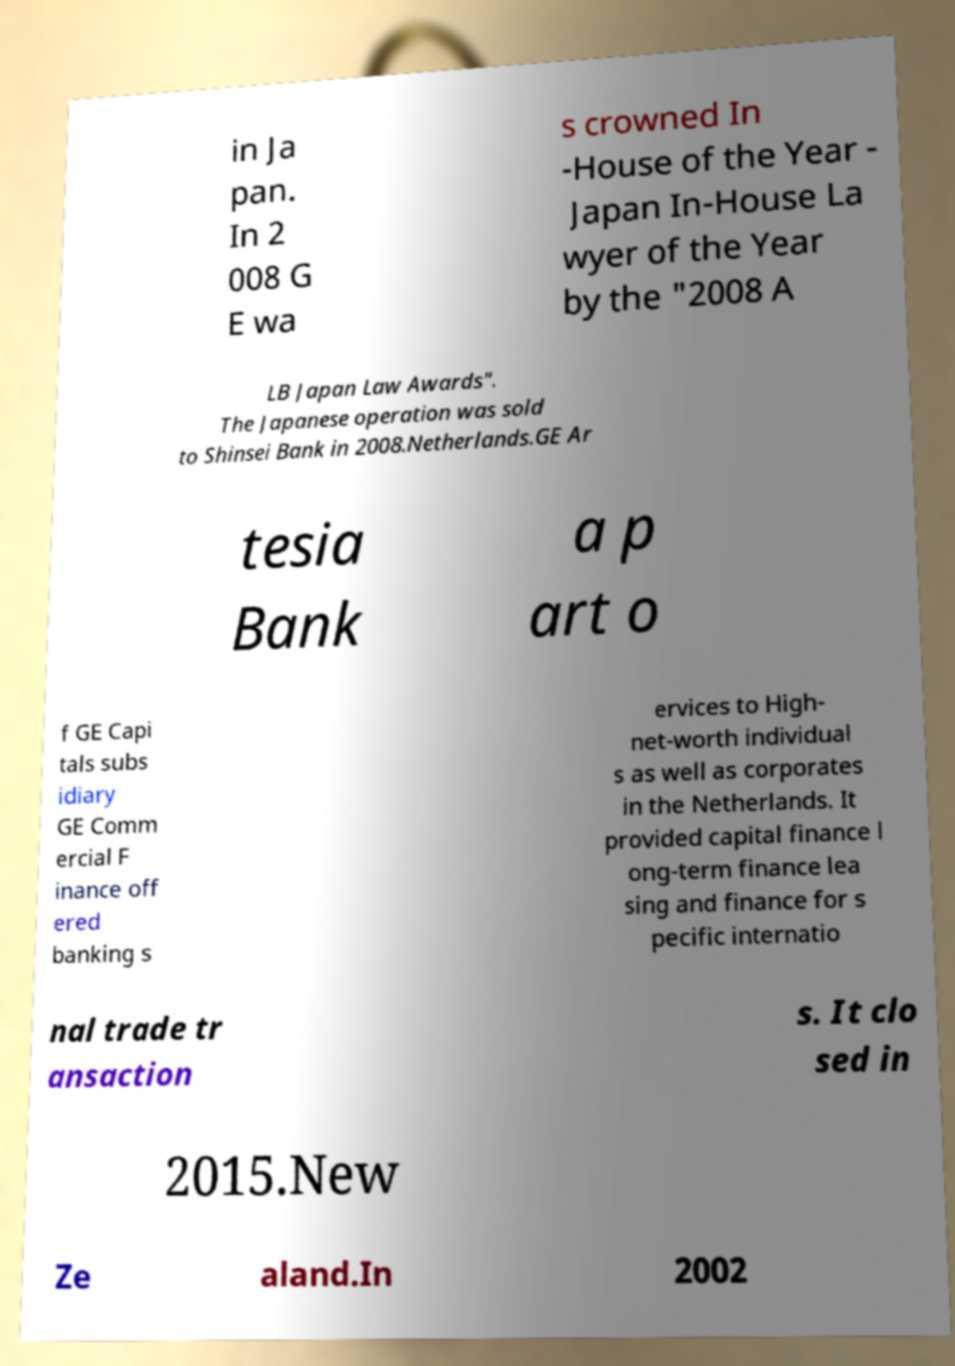For documentation purposes, I need the text within this image transcribed. Could you provide that? in Ja pan. In 2 008 G E wa s crowned In -House of the Year - Japan In-House La wyer of the Year by the "2008 A LB Japan Law Awards". The Japanese operation was sold to Shinsei Bank in 2008.Netherlands.GE Ar tesia Bank a p art o f GE Capi tals subs idiary GE Comm ercial F inance off ered banking s ervices to High- net-worth individual s as well as corporates in the Netherlands. It provided capital finance l ong-term finance lea sing and finance for s pecific internatio nal trade tr ansaction s. It clo sed in 2015.New Ze aland.In 2002 